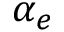<formula> <loc_0><loc_0><loc_500><loc_500>\alpha _ { e }</formula> 